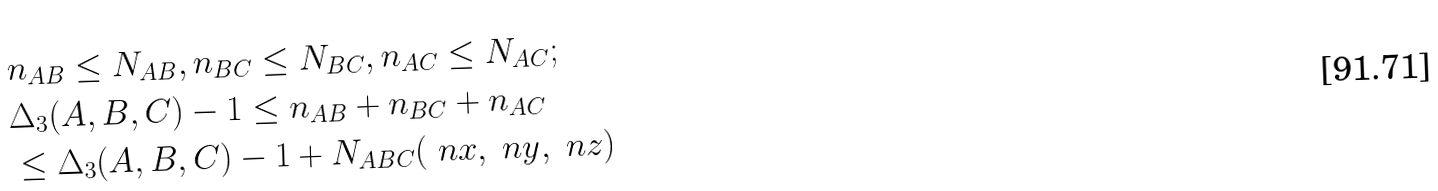<formula> <loc_0><loc_0><loc_500><loc_500>& n _ { A B } \leq N _ { A B } , n _ { B C } \leq N _ { B C } , n _ { A C } \leq N _ { A C } ; \\ & \Delta _ { 3 } ( A , B , C ) - 1 \leq n _ { A B } + n _ { B C } + n _ { A C } \\ & \leq \Delta _ { 3 } ( A , B , C ) - 1 + N _ { A B C } ( \ n x , \ n y , \ n z )</formula> 